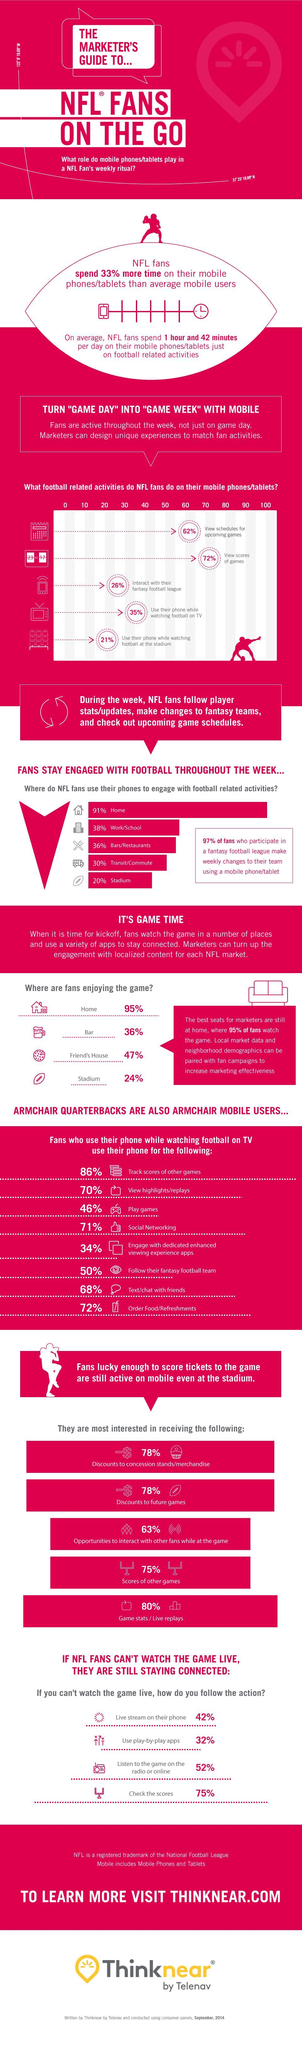What percentage of NFL fans use their phones at home to engage with football-related activities through out the week?
Answer the question with a short phrase. 91% What percentage of NFL fans do social networking while watching football on TV? 71% What percentage of NFL fans use their phones at the stadium to engage with football-related activities throughout the week? 20% What percentage of NFL fans track scores of other games while watching football on TV? 86% What is the average time spend per day by NFL fans on their mobile phones/tablets only for football-related activities? 1 hour and 42 minutes Where do most of the NFL fans enjoy the game? Home Where do NFL fans use their phones the least to engage with football-related activities? Stadium What percent of NFL fans use their mobile phones/tablets to interact with their fantasy football league? 26% What football-related activities do the majority of the NFL fans do on their mobile phones/tablets? View scores of games What percent of NFL fans use play-by-play apps if they can't watch the game live? 32% 